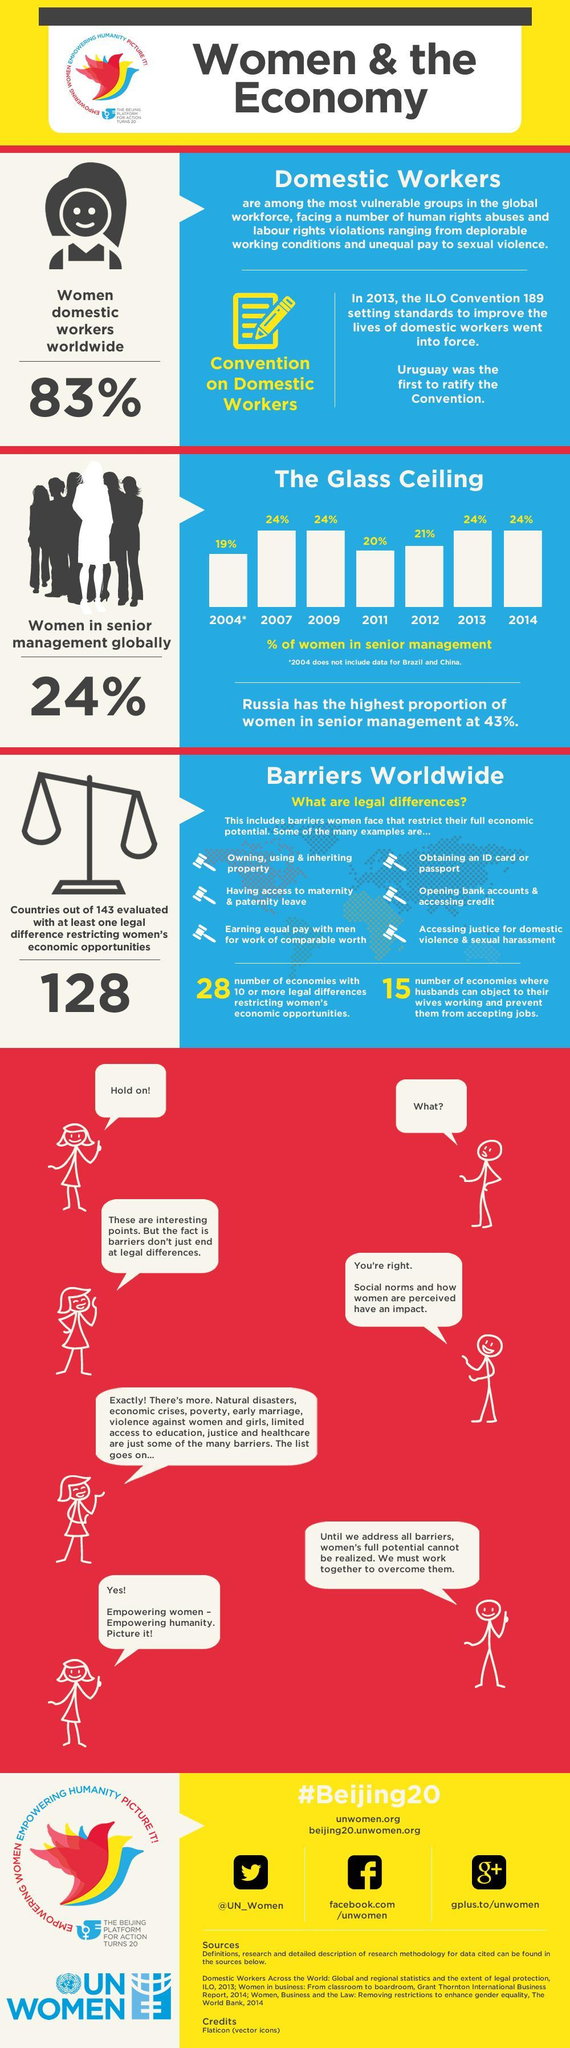What percentage of women are domestic workers worldwide?
Answer the question with a short phrase. 83% Which was the first country to ratify ILO domestic work Convention? Uruguay How many countries have evaluated with at least one legal difference restricting women's  economic opportunities out of 143 countries? 128 What is the number of economies with more than 10 legal differences restricting women's economic opportunities? 28 What percentage of women are in senior management globally in 2012? 21% 